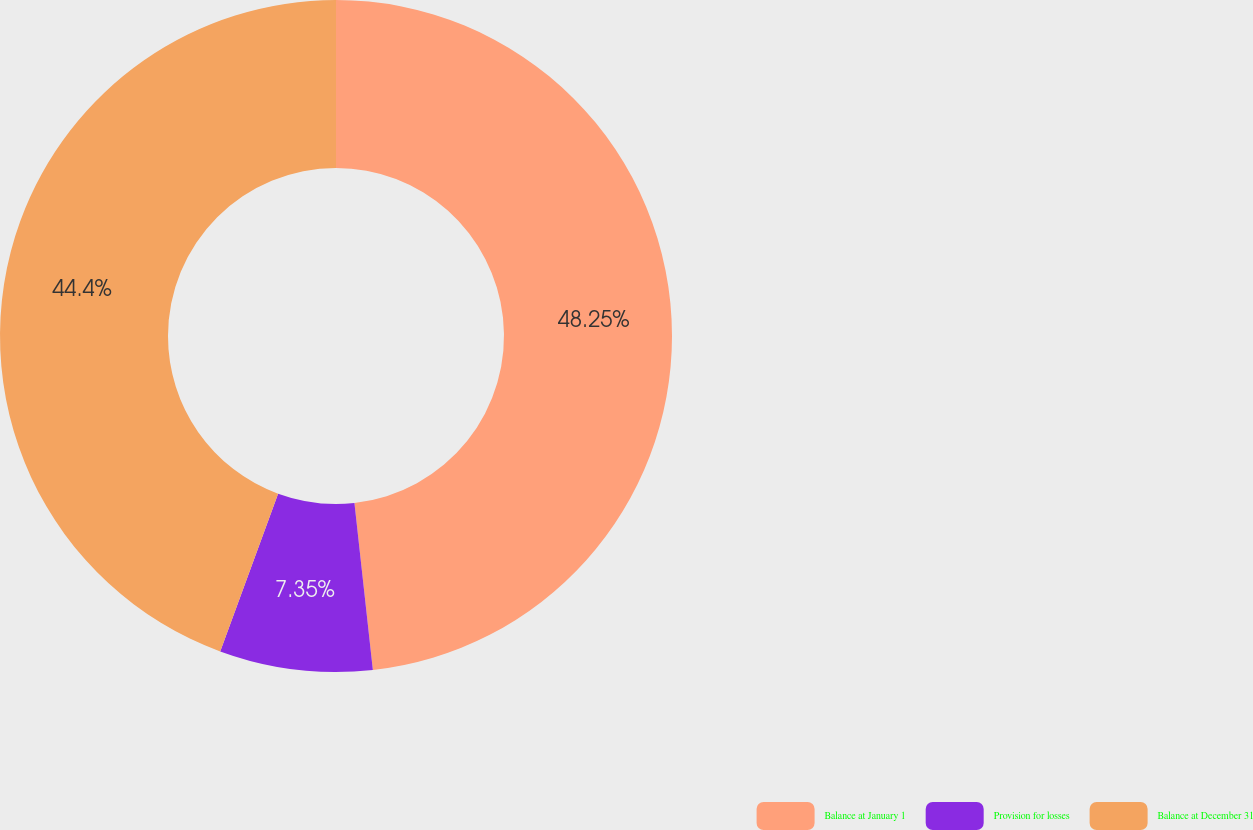Convert chart to OTSL. <chart><loc_0><loc_0><loc_500><loc_500><pie_chart><fcel>Balance at January 1<fcel>Provision for losses<fcel>Balance at December 31<nl><fcel>48.25%<fcel>7.35%<fcel>44.4%<nl></chart> 